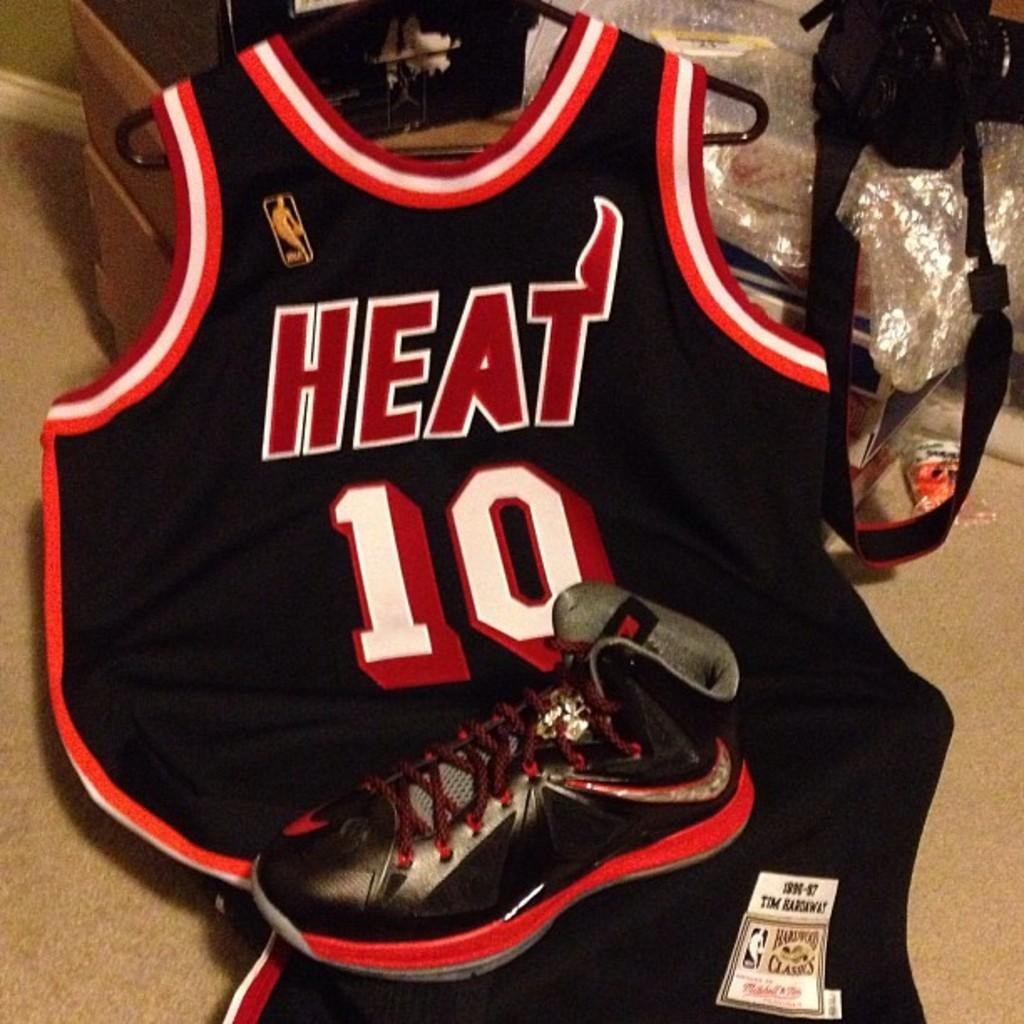Provide a one-sentence caption for the provided image. A player wears Number Ten in the Heat basketball team. 